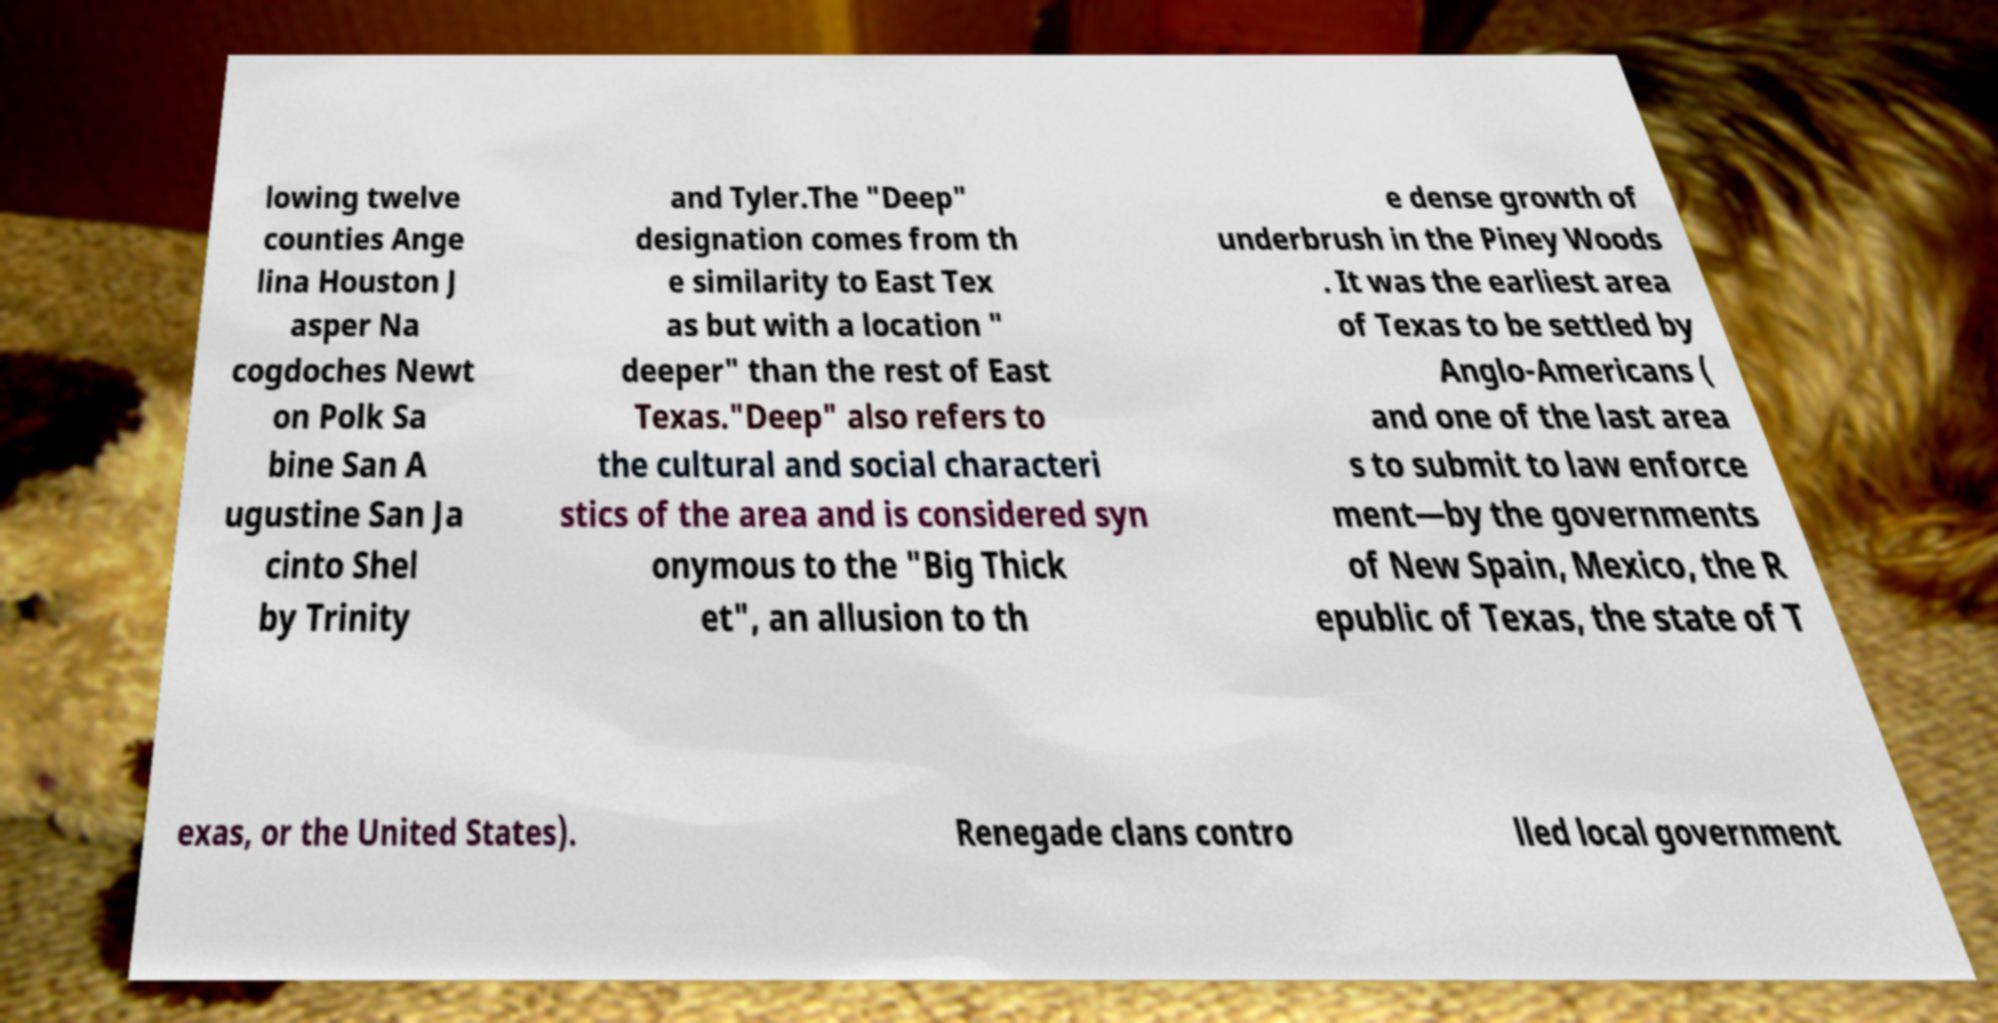I need the written content from this picture converted into text. Can you do that? lowing twelve counties Ange lina Houston J asper Na cogdoches Newt on Polk Sa bine San A ugustine San Ja cinto Shel by Trinity and Tyler.The "Deep" designation comes from th e similarity to East Tex as but with a location " deeper" than the rest of East Texas."Deep" also refers to the cultural and social characteri stics of the area and is considered syn onymous to the "Big Thick et", an allusion to th e dense growth of underbrush in the Piney Woods . It was the earliest area of Texas to be settled by Anglo-Americans ( and one of the last area s to submit to law enforce ment—by the governments of New Spain, Mexico, the R epublic of Texas, the state of T exas, or the United States). Renegade clans contro lled local government 